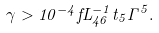Convert formula to latex. <formula><loc_0><loc_0><loc_500><loc_500>\gamma > 1 0 ^ { - 4 } f L _ { 4 6 } ^ { - 1 } t _ { 5 } \Gamma ^ { 5 } .</formula> 